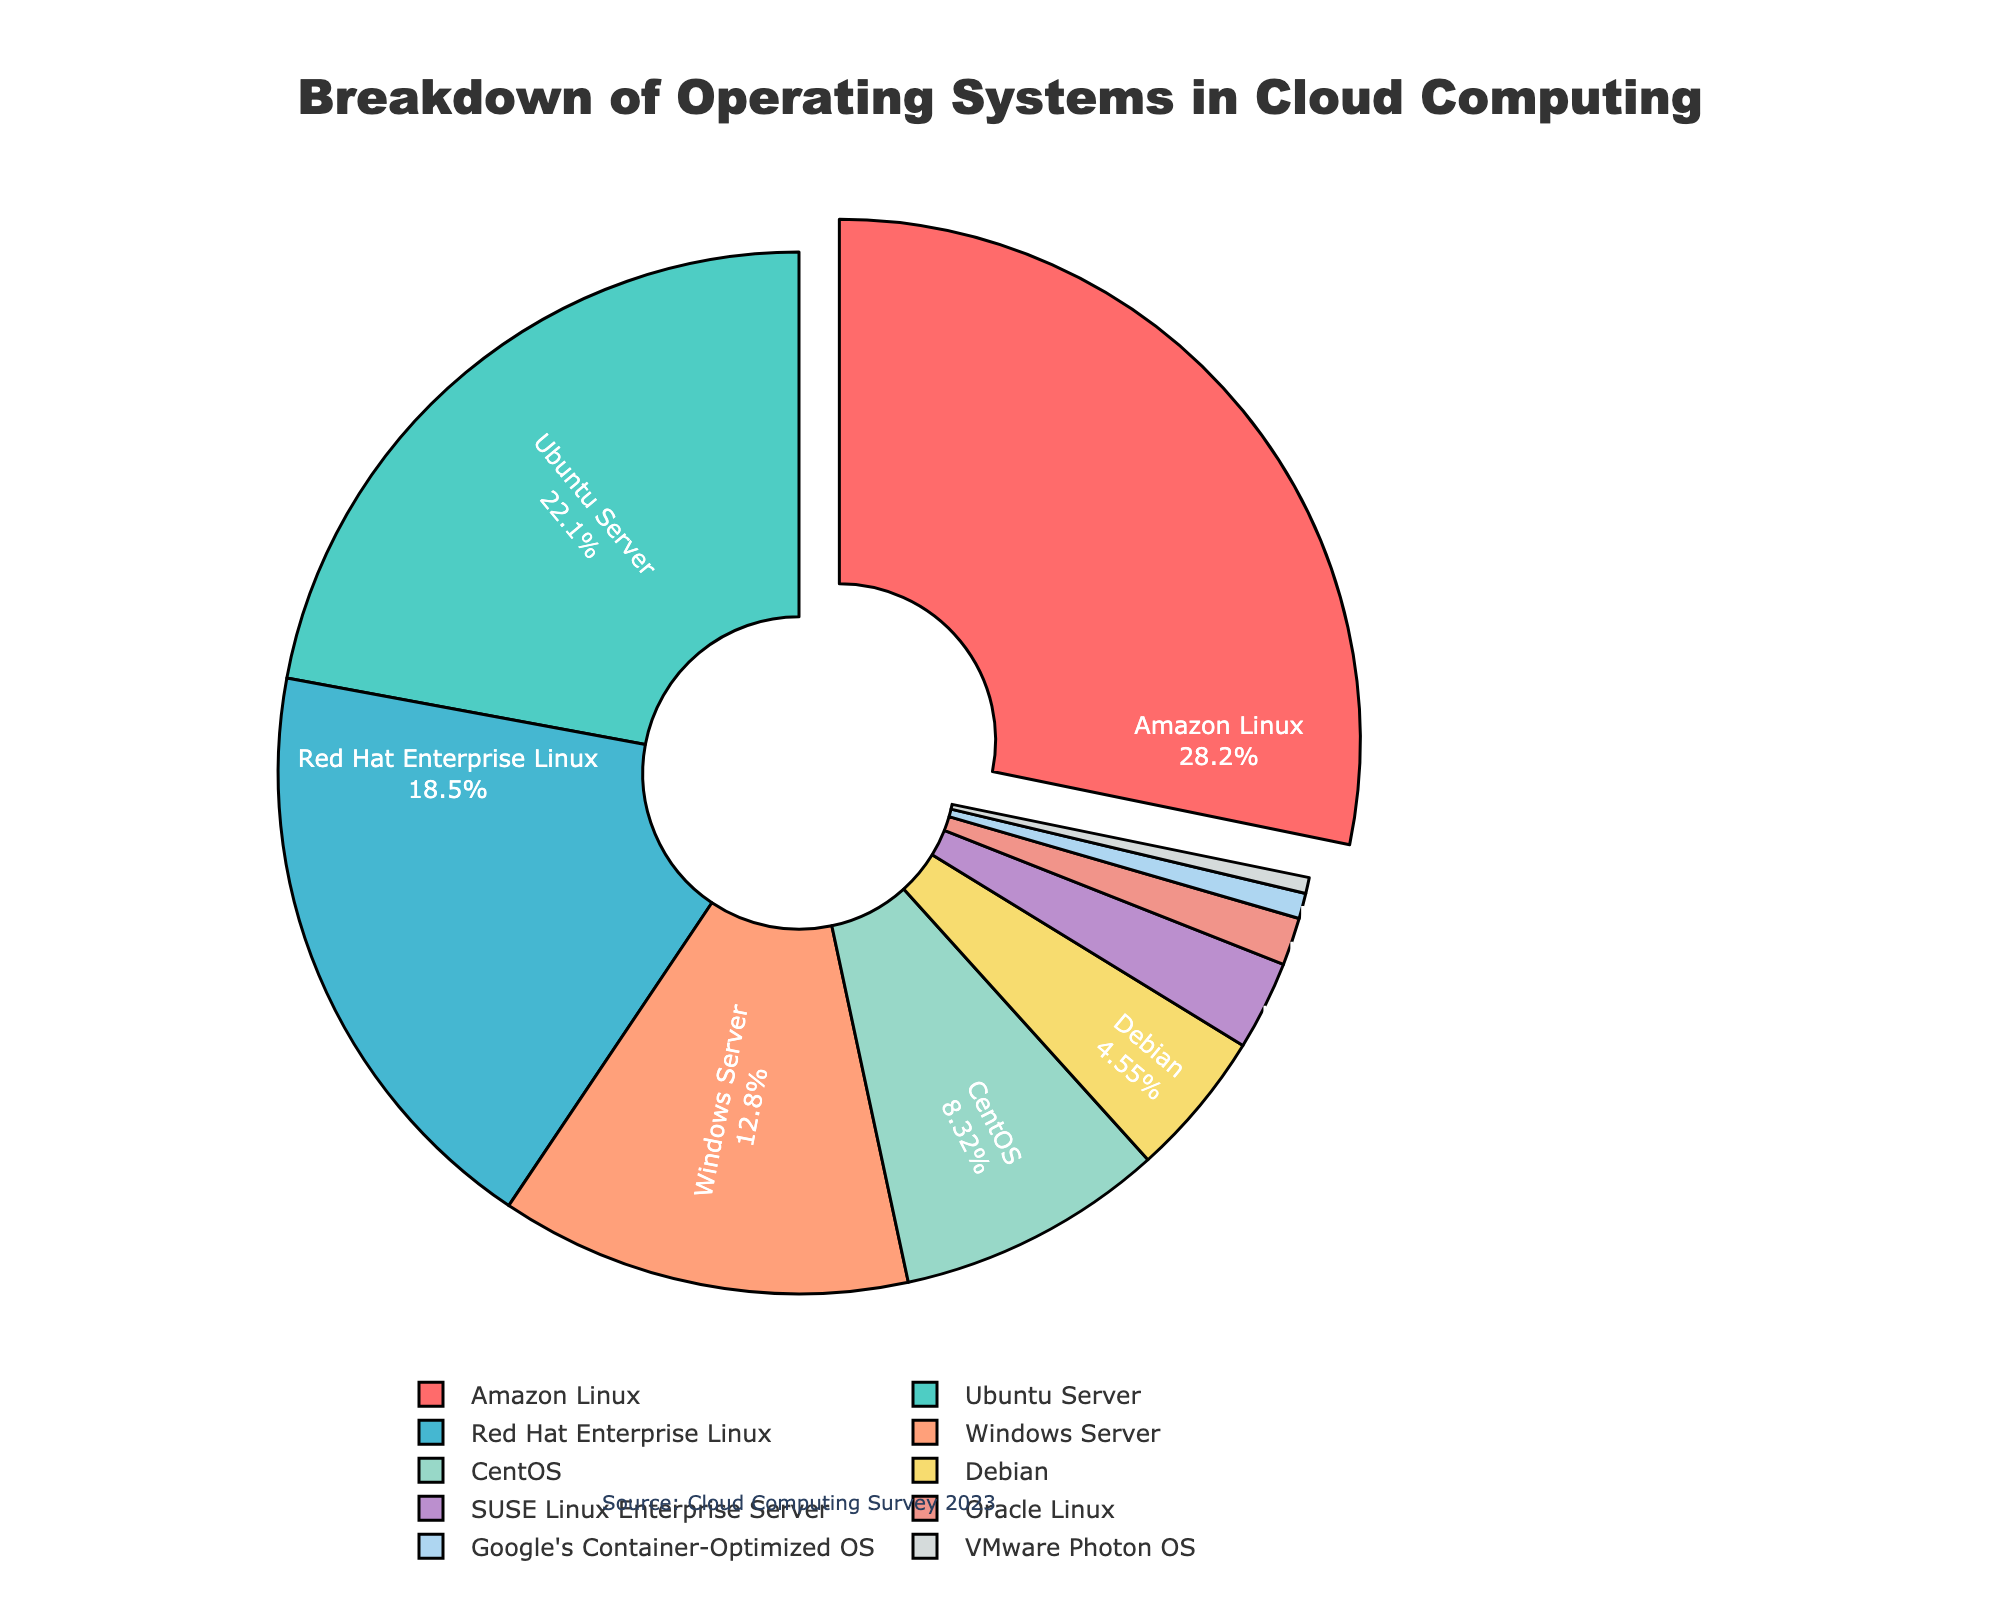what is the most popular operating system used in cloud computing environments? The figure highlights that Amazon Linux is pulled out slightly from the pie, indicating it's the most popular. The percentage displayed shows it has the highest usage.
Answer: Amazon Linux which operating system is used more, Ubuntu Server or Windows Server? By comparing the percentages listed for each, Ubuntu Server has a higher percentage of 22.3% compared to Windows Server's 12.9%.
Answer: Ubuntu Server how much more is the combined usage of Red Hat Enterprise Linux and CentOS compared to Debian? First, add the percentages for Red Hat Enterprise Linux (18.7%) and CentOS (8.4%), which gives 27.1%. Then, subtract Debian's percentage (4.6%) from this sum. 27.1% - 4.6% = 22.5%.
Answer: 22.5% which operating system occupies the smallest segment of the pie chart? The smallest segment in the pie chart is shown at the bottom with the percentage of 0.5%, which corresponds to VMware Photon OS.
Answer: VMware Photon OS how does the combined usage of Oracle Linux and Google's Container-Optimized OS compare to Debian? Add Oracle Linux's percentage (1.5%) and Google's Container-Optimized OS's percentage (0.8%) to get 2.3%. Compare this to Debian's percentage of 4.6%. Since 2.3% is less than 4.6%, Debian has a higher usage.
Answer: Debian which operating system has the fifth largest percentage? List the percentages in descending order: Amazon Linux (28.5%), Ubuntu Server (22.3%), Red Hat Enterprise Linux (18.7%), Windows Server (12.9%), CentOS (8.4%). The fifth largest is CentOS at 8.4%.
Answer: CentOS what are the combined percentages of all Linux-based operating systems in the figure? Sum the percentages for all listed Linux-based operating systems: Amazon Linux (28.5%), Ubuntu Server (22.3%), Red Hat Enterprise Linux (18.7%), CentOS (8.4%), Debian (4.6%), SUSE Linux Enterprise Server (2.8%), Oracle Linux (1.5%), and VMware Photon OS (0.5%). The sum is 87.3%.
Answer: 87.3% does Windows Server usage exceed all other operating systems? Windows Server usage is 12.9%, which is less than the usage of several other operating systems like Amazon Linux (28.5%), Ubuntu Server (22.3%), and Red Hat Enterprise Linux (18.7%).
Answer: No 